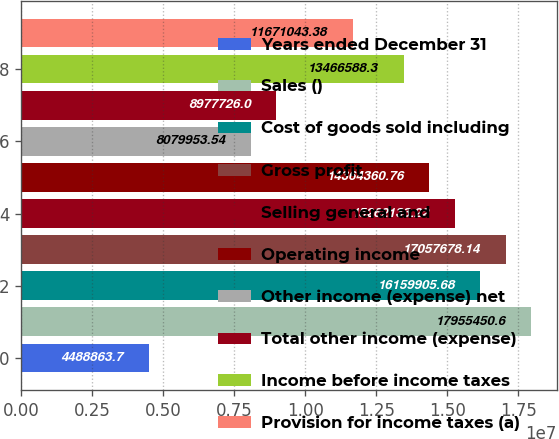Convert chart. <chart><loc_0><loc_0><loc_500><loc_500><bar_chart><fcel>Years ended December 31<fcel>Sales ()<fcel>Cost of goods sold including<fcel>Gross profit<fcel>Selling general and<fcel>Operating income<fcel>Other income (expense) net<fcel>Total other income (expense)<fcel>Income before income taxes<fcel>Provision for income taxes (a)<nl><fcel>4.48886e+06<fcel>1.79555e+07<fcel>1.61599e+07<fcel>1.70577e+07<fcel>1.52621e+07<fcel>1.43644e+07<fcel>8.07995e+06<fcel>8.97773e+06<fcel>1.34666e+07<fcel>1.1671e+07<nl></chart> 